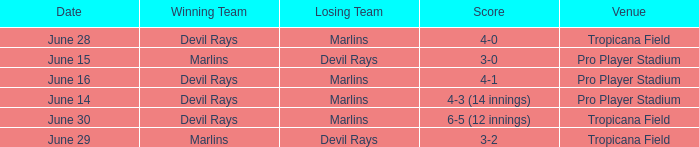Who won by a score of 4-1? Devil Rays. 